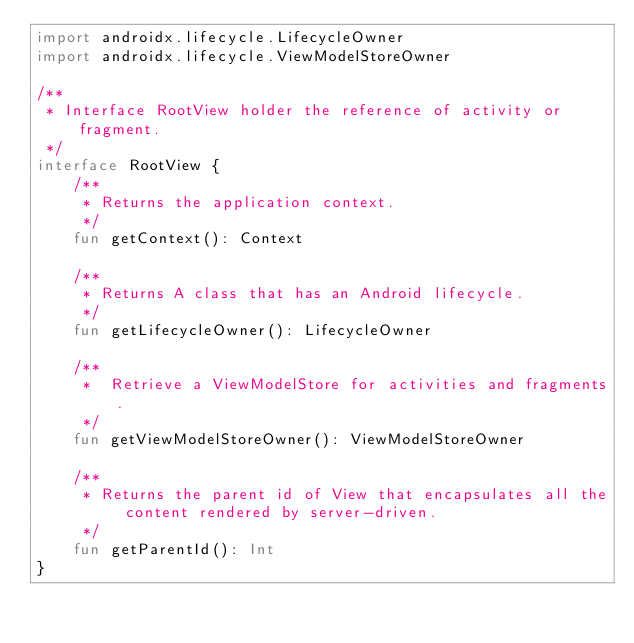<code> <loc_0><loc_0><loc_500><loc_500><_Kotlin_>import androidx.lifecycle.LifecycleOwner
import androidx.lifecycle.ViewModelStoreOwner

/**
 * Interface RootView holder the reference of activity or fragment.
 */
interface RootView {
    /**
     * Returns the application context.
     */
    fun getContext(): Context

    /**
     * Returns A class that has an Android lifecycle.
     */
    fun getLifecycleOwner(): LifecycleOwner

    /**
     *  Retrieve a ViewModelStore for activities and fragments.
     */
    fun getViewModelStoreOwner(): ViewModelStoreOwner

    /**
     * Returns the parent id of View that encapsulates all the content rendered by server-driven.
     */
    fun getParentId(): Int
}
</code> 